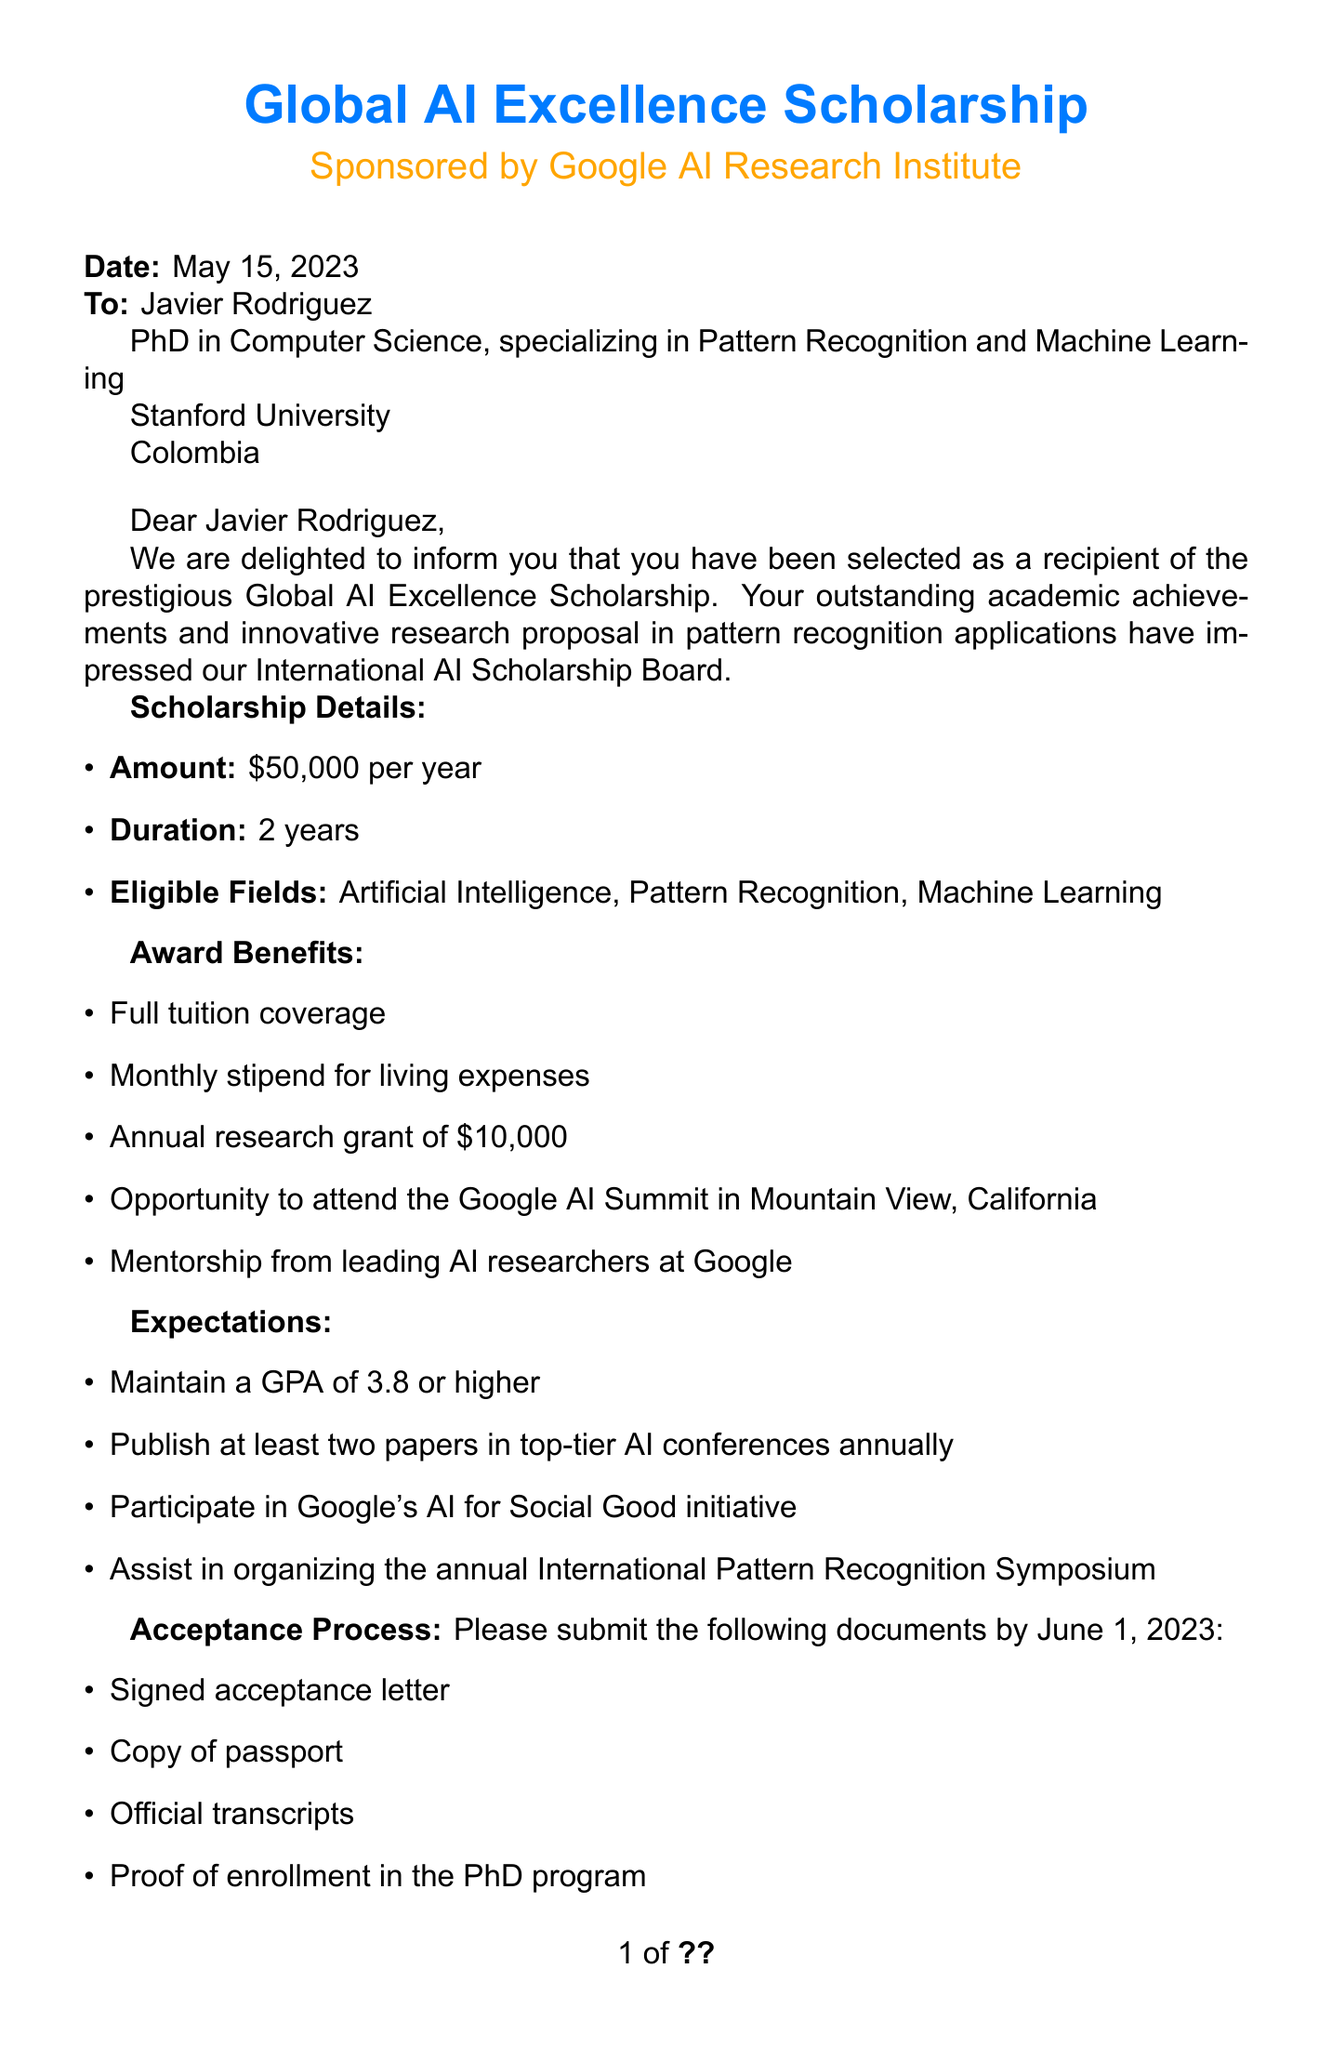What is the name of the scholarship? The name of the scholarship is stated in the document as the Global AI Excellence Scholarship.
Answer: Global AI Excellence Scholarship Who is the sponsor of the scholarship? The document mentions that the scholarship is sponsored by the Google AI Research Institute.
Answer: Google AI Research Institute What is the amount of the scholarship per year? The document specifies the amount of the scholarship as $50,000 per year.
Answer: $50,000 How many awards were given in total? The document states that 25 awards were given out to applicants.
Answer: 25 What is the deadline for document submission? According to the document, the deadline for submission of required documents is June 1, 2023.
Answer: June 1, 2023 Which institution is Javier Rodriguez affiliated with? The document indicates that Javier Rodriguez is currently affiliated with Stanford University.
Answer: Stanford University What GPA must be maintained to fulfill scholarship expectations? The document specifies that a GPA of 3.8 or higher must be maintained.
Answer: 3.8 When is the orientation date? The document mentions that the orientation date is August 15, 2023.
Answer: August 15, 2023 What type of program is Javier Rodriguez enrolled in? According to the document, Javier Rodriguez is enrolled in a PhD in Computer Science, specializing in Pattern Recognition and Machine Learning.
Answer: PhD in Computer Science, specializing in Pattern Recognition and Machine Learning 